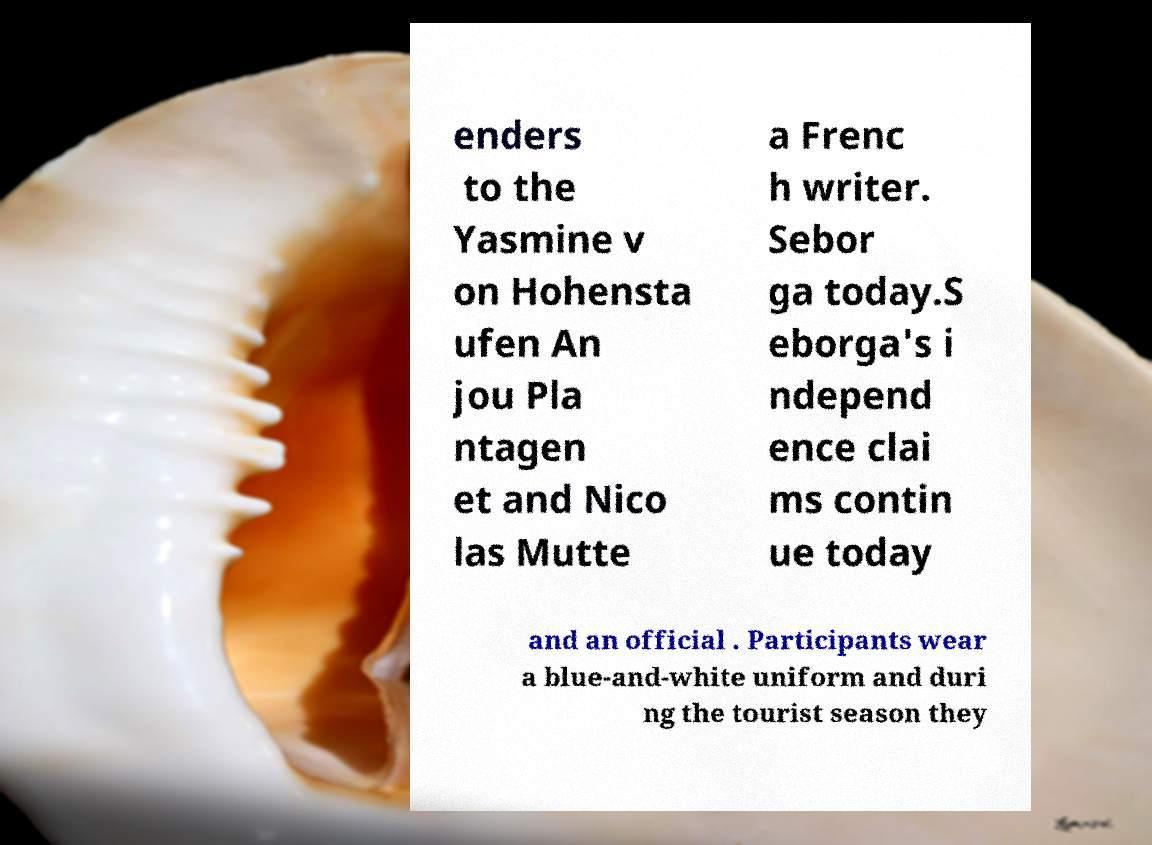Could you assist in decoding the text presented in this image and type it out clearly? enders to the Yasmine v on Hohensta ufen An jou Pla ntagen et and Nico las Mutte a Frenc h writer. Sebor ga today.S eborga's i ndepend ence clai ms contin ue today and an official . Participants wear a blue-and-white uniform and duri ng the tourist season they 